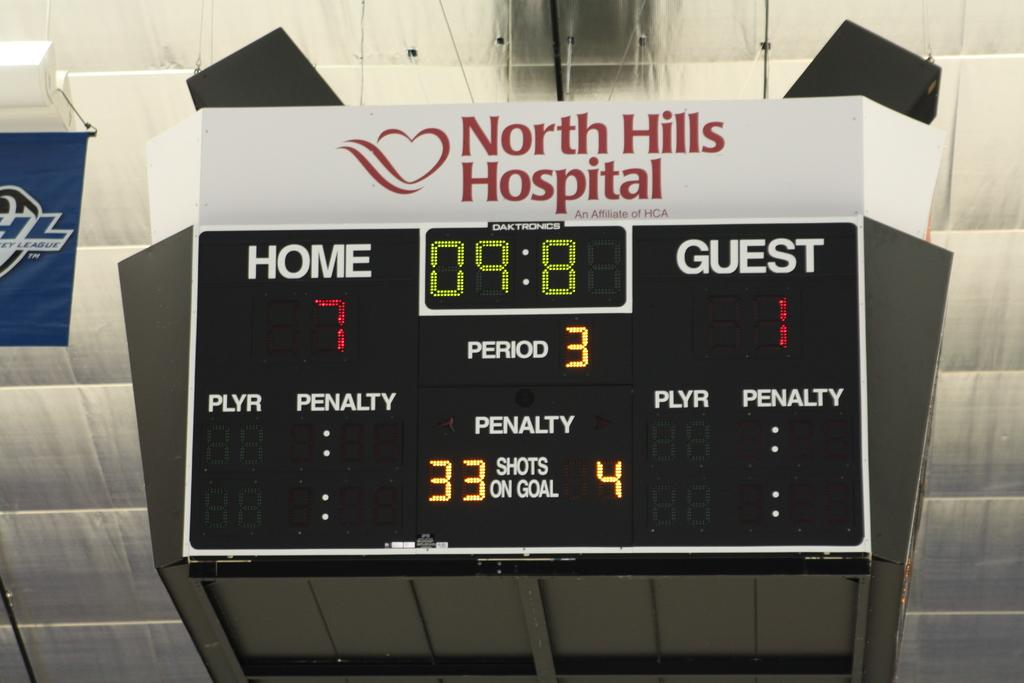<image>
Relay a brief, clear account of the picture shown. The score board at a sports game that was built with money from North Hills Hospital. 